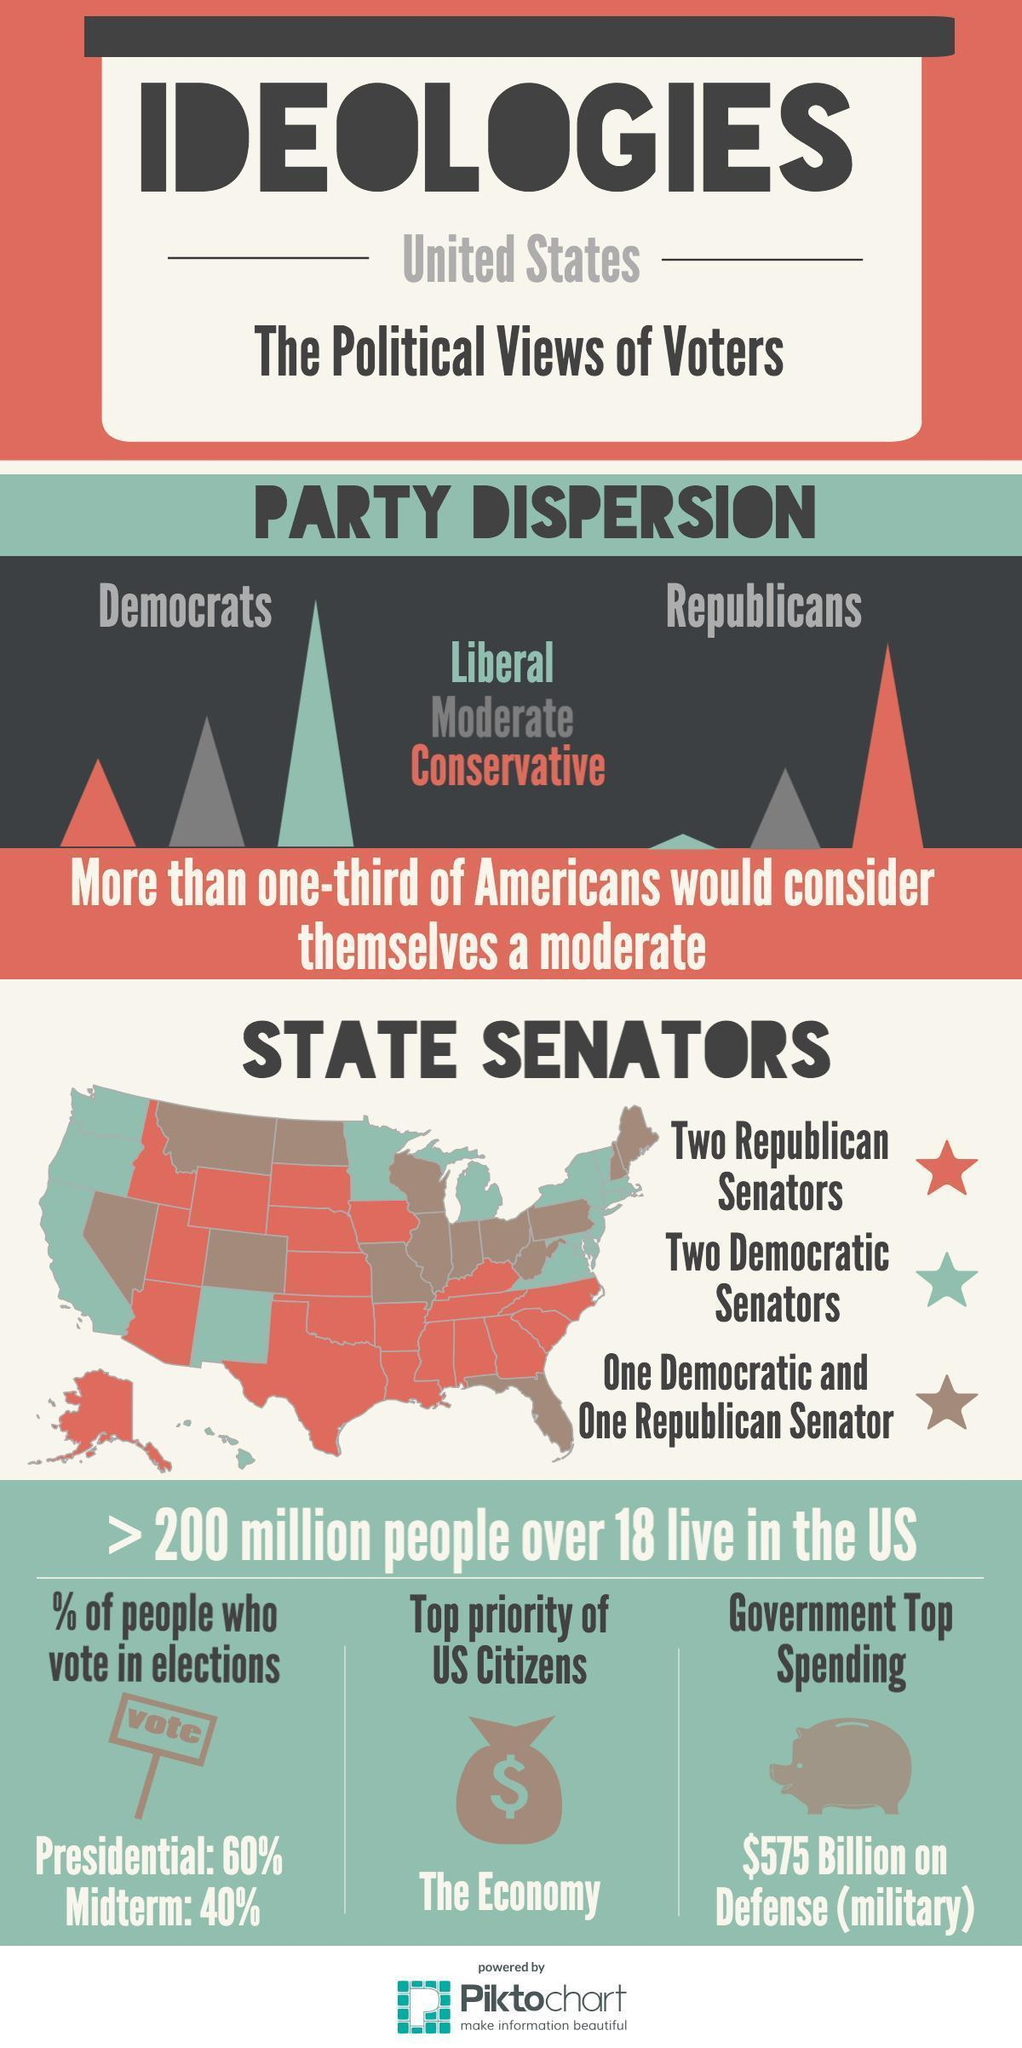Which party has the second-highest power among Republicans in the United States?
Answer the question with a short phrase. Moderate Which party has the third-highest power among Republicans in the United States? Liberal Which party has the highest power among Republicans in the United States? Conservative Which party has the third-highest power among Democrats in the United States? Conservative What is the top priority of US citizens? The Economy What is the largest expenditure for the US government? Defense (Military) What is the inverse percentage of people who participate in the Presidential election? 40 Which party has the highest power among Democrats in the United States? Liberal Which party has the second-highest power among Democrats in the United States? Moderate What is the inverse percentage of people who participate in the Midterm election? 60 